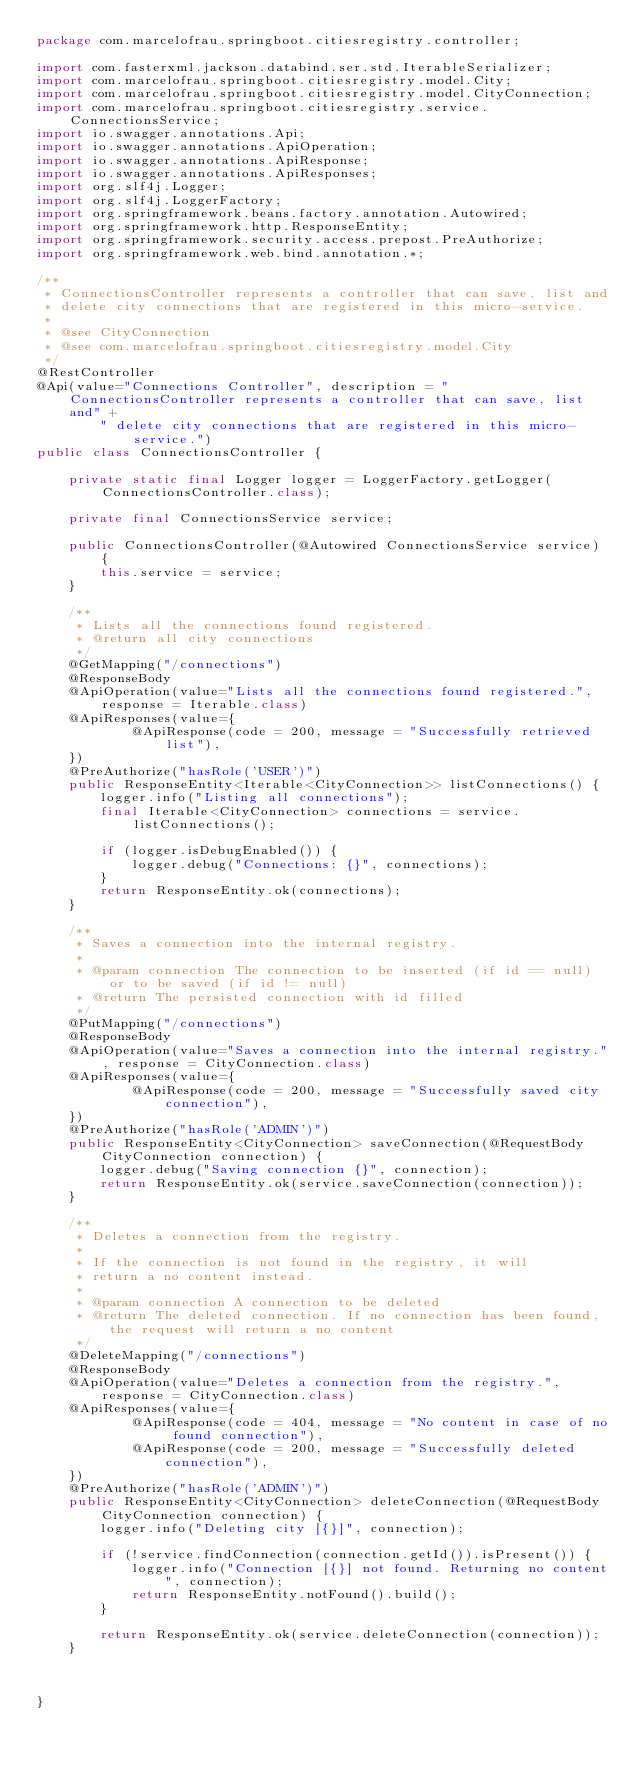<code> <loc_0><loc_0><loc_500><loc_500><_Java_>package com.marcelofrau.springboot.citiesregistry.controller;

import com.fasterxml.jackson.databind.ser.std.IterableSerializer;
import com.marcelofrau.springboot.citiesregistry.model.City;
import com.marcelofrau.springboot.citiesregistry.model.CityConnection;
import com.marcelofrau.springboot.citiesregistry.service.ConnectionsService;
import io.swagger.annotations.Api;
import io.swagger.annotations.ApiOperation;
import io.swagger.annotations.ApiResponse;
import io.swagger.annotations.ApiResponses;
import org.slf4j.Logger;
import org.slf4j.LoggerFactory;
import org.springframework.beans.factory.annotation.Autowired;
import org.springframework.http.ResponseEntity;
import org.springframework.security.access.prepost.PreAuthorize;
import org.springframework.web.bind.annotation.*;

/**
 * ConnectionsController represents a controller that can save, list and
 * delete city connections that are registered in this micro-service.
 *
 * @see CityConnection
 * @see com.marcelofrau.springboot.citiesregistry.model.City
 */
@RestController
@Api(value="Connections Controller", description = "ConnectionsController represents a controller that can save, list and" +
        " delete city connections that are registered in this micro-service.")
public class ConnectionsController {

    private static final Logger logger = LoggerFactory.getLogger(ConnectionsController.class);

    private final ConnectionsService service;

    public ConnectionsController(@Autowired ConnectionsService service) {
        this.service = service;
    }

    /**
     * Lists all the connections found registered.
     * @return all city connections
     */
    @GetMapping("/connections")
    @ResponseBody
    @ApiOperation(value="Lists all the connections found registered.", response = Iterable.class)
    @ApiResponses(value={
            @ApiResponse(code = 200, message = "Successfully retrieved list"),
    })
    @PreAuthorize("hasRole('USER')")
    public ResponseEntity<Iterable<CityConnection>> listConnections() {
        logger.info("Listing all connections");
        final Iterable<CityConnection> connections = service.listConnections();

        if (logger.isDebugEnabled()) {
            logger.debug("Connections: {}", connections);
        }
        return ResponseEntity.ok(connections);
    }

    /**
     * Saves a connection into the internal registry.
     *
     * @param connection The connection to be inserted (if id == null) or to be saved (if id != null)
     * @return The persisted connection with id filled
     */
    @PutMapping("/connections")
    @ResponseBody
    @ApiOperation(value="Saves a connection into the internal registry.", response = CityConnection.class)
    @ApiResponses(value={
            @ApiResponse(code = 200, message = "Successfully saved city connection"),
    })
    @PreAuthorize("hasRole('ADMIN')")
    public ResponseEntity<CityConnection> saveConnection(@RequestBody CityConnection connection) {
        logger.debug("Saving connection {}", connection);
        return ResponseEntity.ok(service.saveConnection(connection));
    }

    /**
     * Deletes a connection from the registry.
     *
     * If the connection is not found in the registry, it will
     * return a no content instead.
     *
     * @param connection A connection to be deleted
     * @return The deleted connection. If no connection has been found, the request will return a no content
     */
    @DeleteMapping("/connections")
    @ResponseBody
    @ApiOperation(value="Deletes a connection from the registry.", response = CityConnection.class)
    @ApiResponses(value={
            @ApiResponse(code = 404, message = "No content in case of no found connection"),
            @ApiResponse(code = 200, message = "Successfully deleted connection"),
    })
    @PreAuthorize("hasRole('ADMIN')")
    public ResponseEntity<CityConnection> deleteConnection(@RequestBody CityConnection connection) {
        logger.info("Deleting city [{}]", connection);

        if (!service.findConnection(connection.getId()).isPresent()) {
            logger.info("Connection [{}] not found. Returning no content", connection);
            return ResponseEntity.notFound().build();
        }

        return ResponseEntity.ok(service.deleteConnection(connection));
    }



}
</code> 